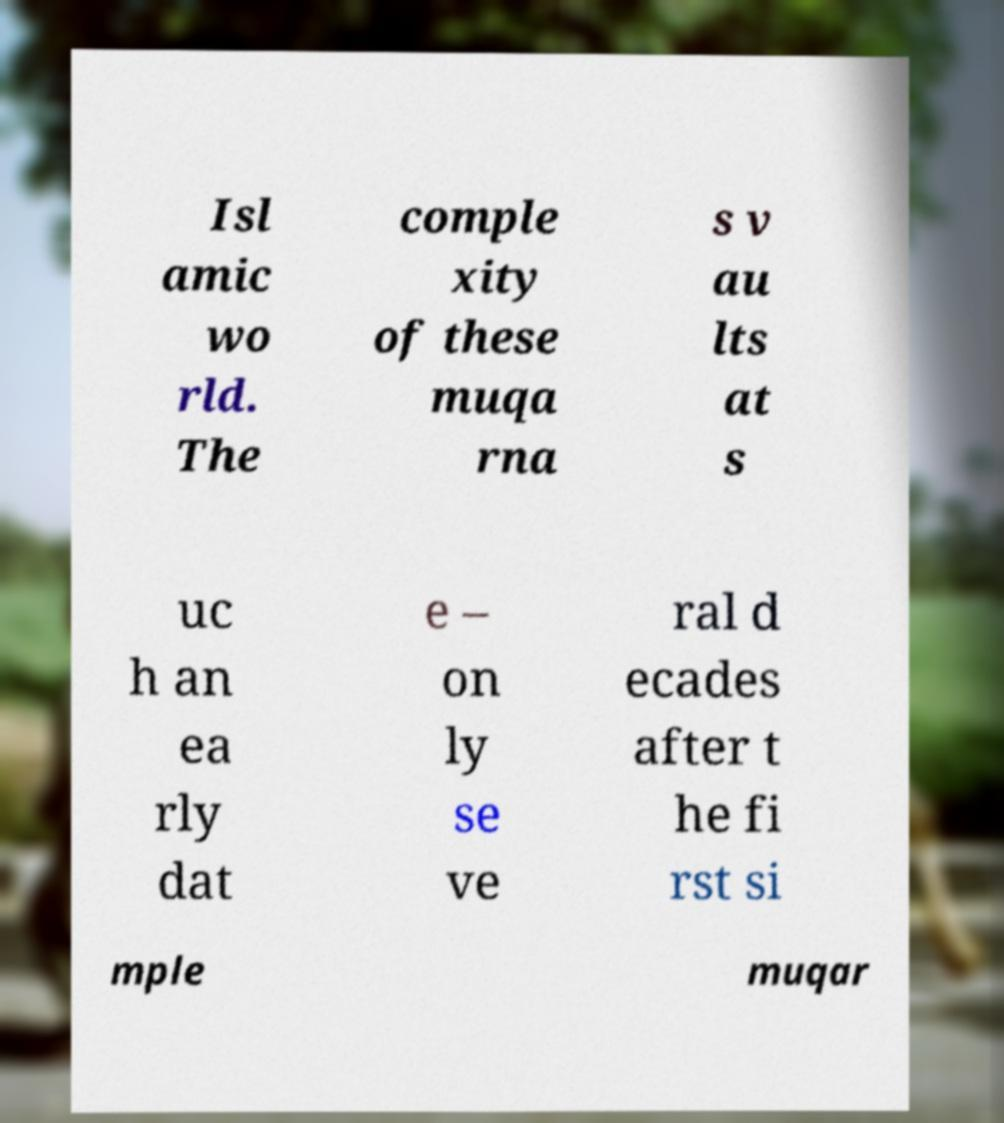Could you assist in decoding the text presented in this image and type it out clearly? Isl amic wo rld. The comple xity of these muqa rna s v au lts at s uc h an ea rly dat e – on ly se ve ral d ecades after t he fi rst si mple muqar 